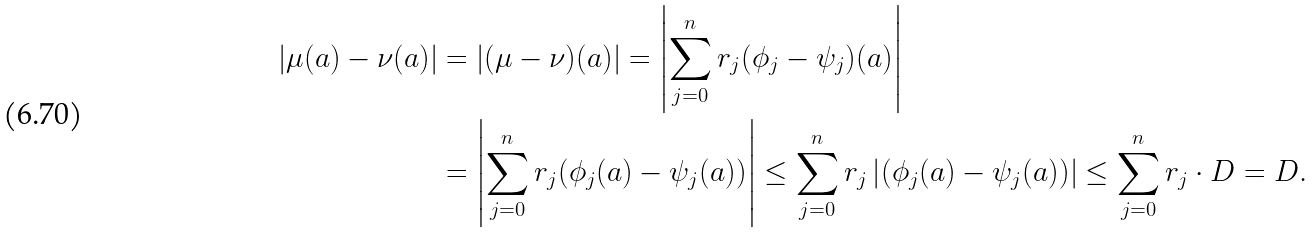Convert formula to latex. <formula><loc_0><loc_0><loc_500><loc_500>| \mu ( a ) - \nu ( a ) | & = | ( \mu - \nu ) ( a ) | = \left | \sum _ { j = 0 } ^ { n } r _ { j } ( \phi _ { j } - \psi _ { j } ) ( a ) \right | \\ & = \left | \sum _ { j = 0 } ^ { n } r _ { j } ( \phi _ { j } ( a ) - \psi _ { j } ( a ) ) \right | \leq \sum _ { j = 0 } ^ { n } r _ { j } \left | ( \phi _ { j } ( a ) - \psi _ { j } ( a ) ) \right | \leq \sum _ { j = 0 } ^ { n } r _ { j } \cdot D = D .</formula> 